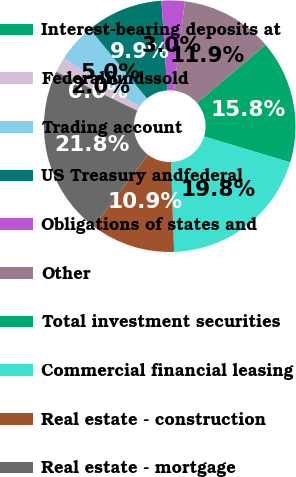<chart> <loc_0><loc_0><loc_500><loc_500><pie_chart><fcel>Interest-bearing deposits at<fcel>Federalfundssold<fcel>Trading account<fcel>US Treasury andfederal<fcel>Obligations of states and<fcel>Other<fcel>Total investment securities<fcel>Commercial financial leasing<fcel>Real estate - construction<fcel>Real estate - mortgage<nl><fcel>0.0%<fcel>1.98%<fcel>4.95%<fcel>9.9%<fcel>2.97%<fcel>11.88%<fcel>15.84%<fcel>19.8%<fcel>10.89%<fcel>21.78%<nl></chart> 